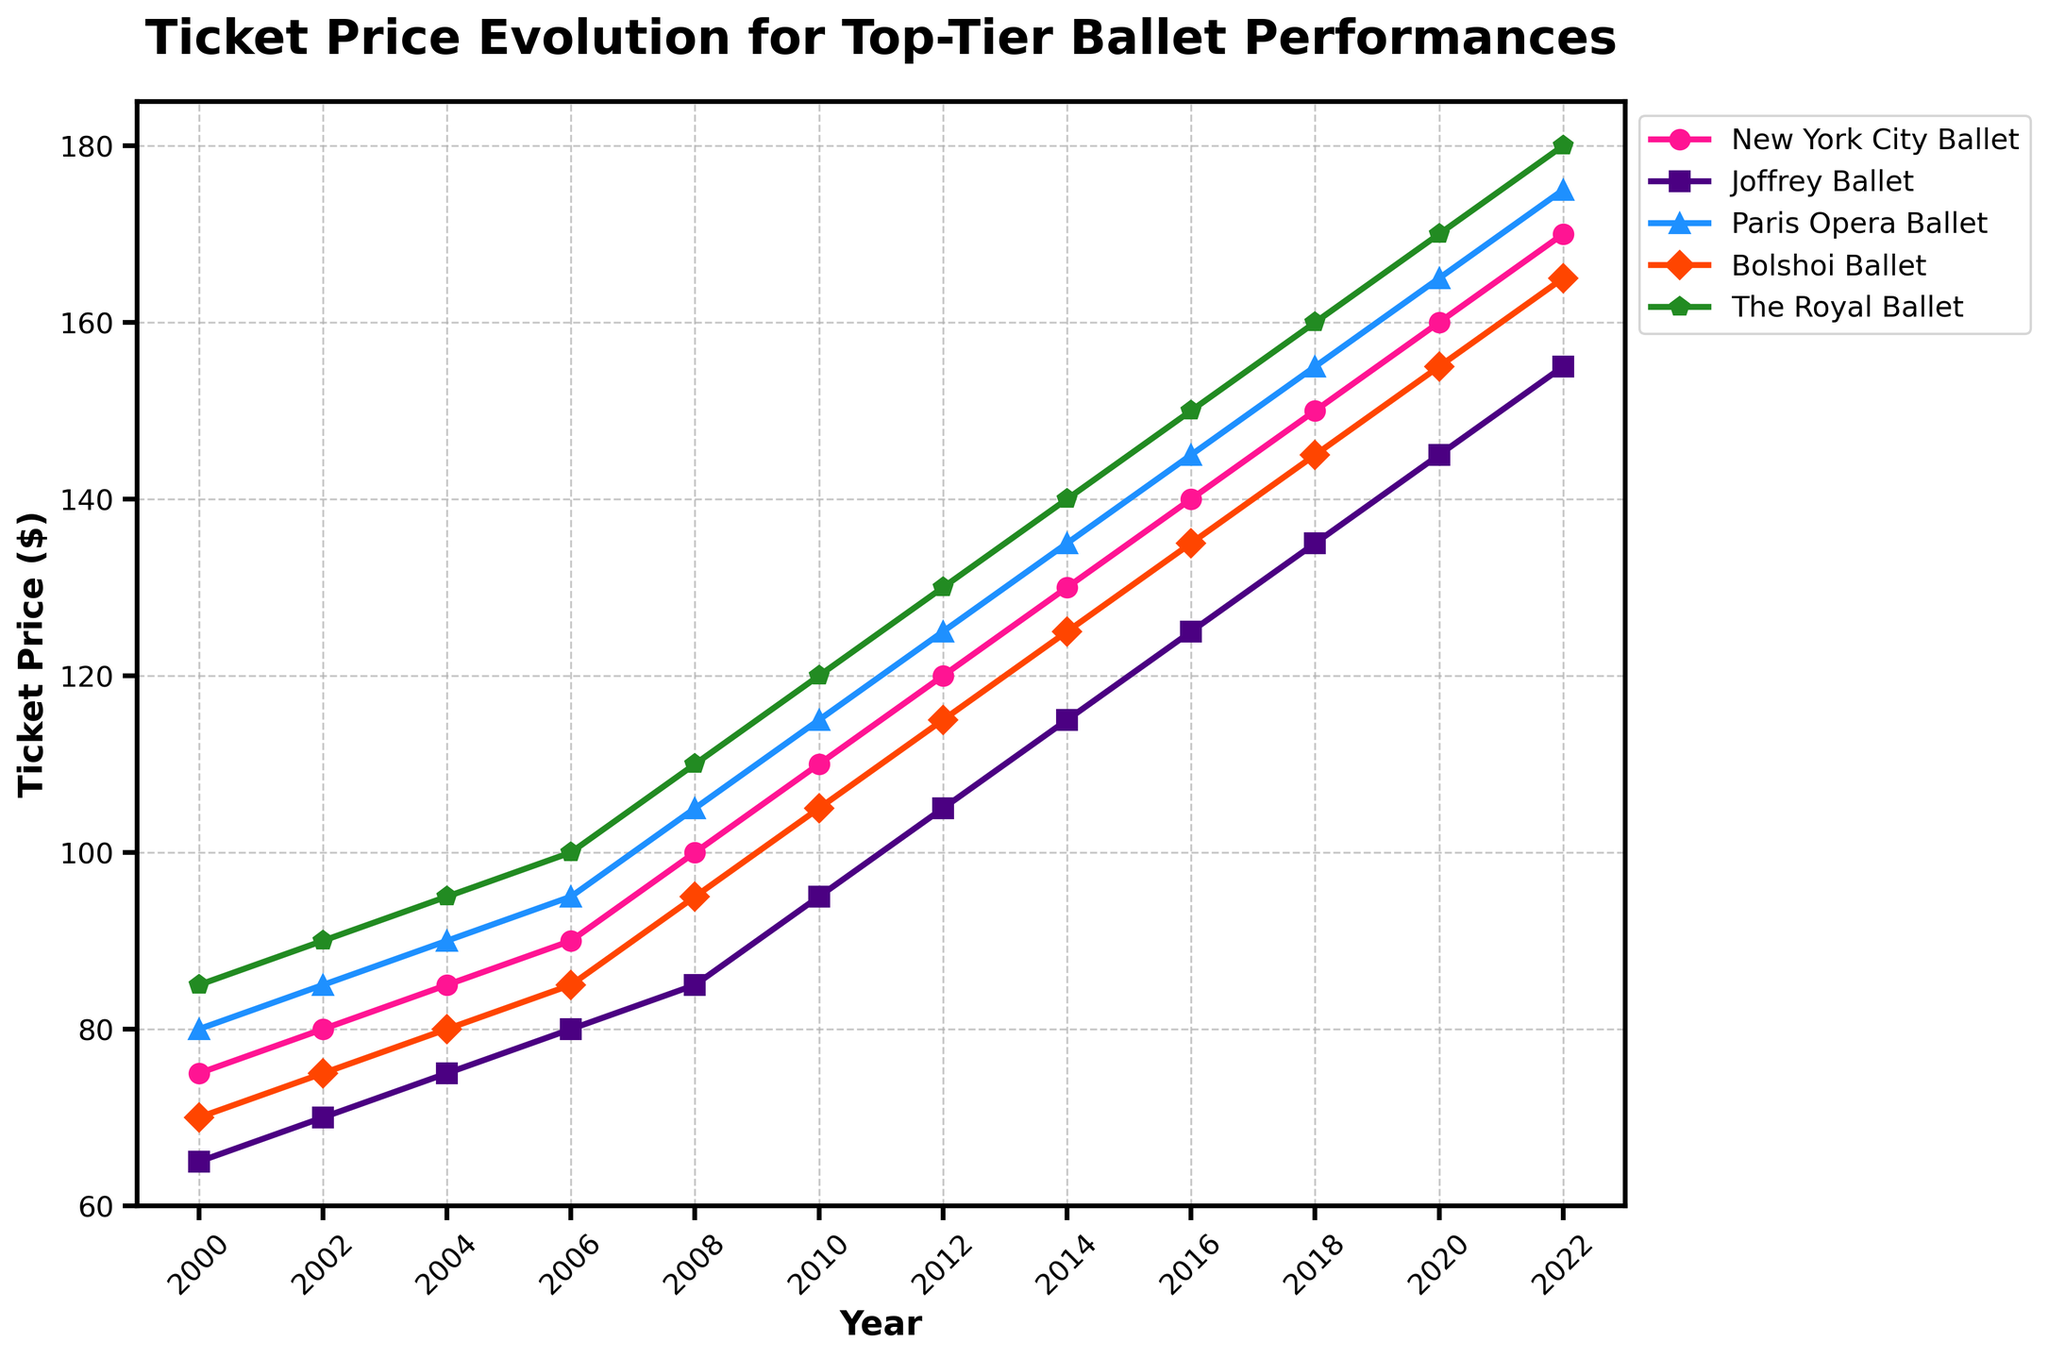What's the overall trend of ticket prices for the Joffrey Ballet from 2000 to 2022? The Joffrey Ballet’s ticket prices show a consistent upward trend from 2000 to 2022, starting at $65 in 2000 and rising steadily to $155 in 2022.
Answer: Increasing Which ballet company had the highest ticket price in 2022? In 2022, the highest ticket price is observed with The Royal Ballet, reaching $180, as shown by the highest point on their line in the plot.
Answer: The Royal Ballet How did the ticket prices for the New York City Ballet and the Bolshoi Ballet compare in 2016? In 2016, the New York City Ballet had a ticket price of $140 and the Bolshoi Ballet had a ticket price of $135.
Answer: New York City Ballet had a higher ticket price Calculate the average ticket price across all companies in 2010. Summing the prices of all companies in 2010: 110 (NYCB) + 95 (JB) + 115 (POB) + 105 (BB) + 120 (TRB) = 545. The average is 545 / 5 = 109.
Answer: 109 Between 2008 and 2018, which ballet company showed the greatest increase in ticket price? In 2008, the Joffrey Ballet ticket price was $85, and in 2018 it was $135, an increase of $50. Comparatively, the Joffrey Ballet had the greatest increase as other companies had smaller increments.
Answer: Joffrey Ballet What is the difference in ticket prices between the Joffrey Ballet and The Royal Ballet in 2020? In 2020, the Joffrey Ballet had a ticket price of $145, and The Royal Ballet had a price of $170. The difference is 170 - 145 = 25.
Answer: 25 Which company had the smallest increase in ticket prices from 2000 to 2022? From 2000 to 2022, the Bolshoi Ballet exhibited the smallest increase, starting at $70 and rising to $165, an increase of $95.
Answer: Bolshoi Ballet How do the ticket prices for the Paris Opera Ballet and Bolshoi Ballet in 2014 compare visually in terms of their line heights? In 2014, the Paris Opera Ballet ticket price line is higher up at $135 compared to the Bolshoi Ballet at $125, indicating that the Paris Opera Ballet had higher ticket prices that year.
Answer: Paris Opera Ballet ticket price is higher What was the ticket price for the New York City Ballet in 2004, and how did it compare to the Joffrey Ballet in the same year? In 2004, the New York City Ballet had a ticket price of $85, while the Joffrey Ballet had a price of $75. The New York City Ballet ticket was $10 more expensive.
Answer: New York City Ballet ticket was $10 more expensive Which ballet company had ticket prices in 2010 closest to the overall average ticket price for that year? The ticket prices in 2010 were $110 (NYCB), $95 (JB), $115 (POB), $105 (BB), and $120 (TRB). The average is 109, and Bolshoi Ballet had a ticket price of $105, which is nearest to the average.
Answer: Bolshoi Ballet 